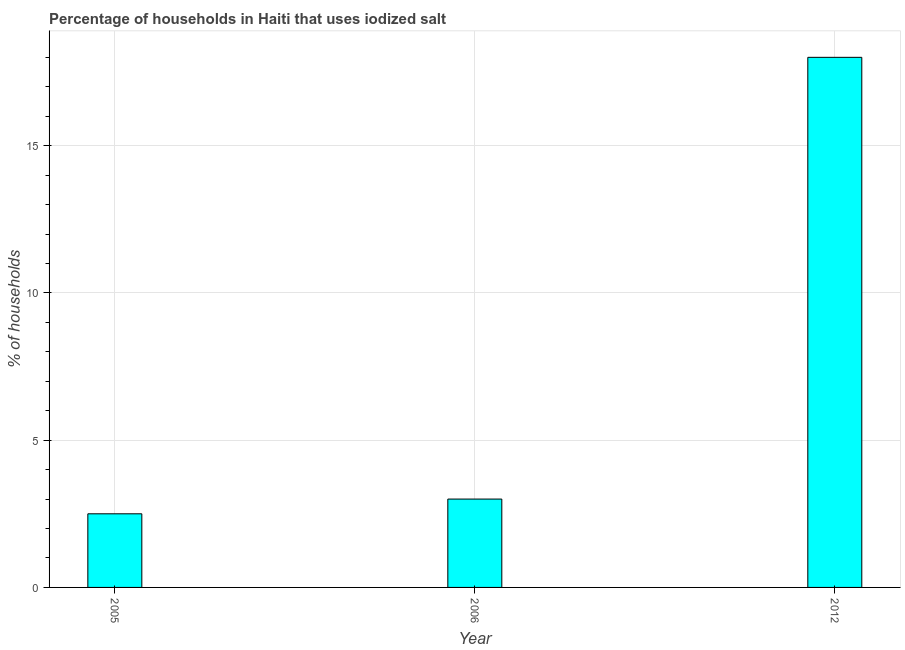Does the graph contain any zero values?
Give a very brief answer. No. What is the title of the graph?
Ensure brevity in your answer.  Percentage of households in Haiti that uses iodized salt. What is the label or title of the X-axis?
Provide a short and direct response. Year. What is the label or title of the Y-axis?
Offer a very short reply. % of households. What is the percentage of households where iodized salt is consumed in 2005?
Keep it short and to the point. 2.5. Across all years, what is the maximum percentage of households where iodized salt is consumed?
Make the answer very short. 18. Across all years, what is the minimum percentage of households where iodized salt is consumed?
Ensure brevity in your answer.  2.5. In which year was the percentage of households where iodized salt is consumed minimum?
Keep it short and to the point. 2005. What is the sum of the percentage of households where iodized salt is consumed?
Give a very brief answer. 23.5. What is the difference between the percentage of households where iodized salt is consumed in 2005 and 2012?
Your response must be concise. -15.5. What is the average percentage of households where iodized salt is consumed per year?
Provide a short and direct response. 7.83. In how many years, is the percentage of households where iodized salt is consumed greater than 13 %?
Your answer should be compact. 1. What is the ratio of the percentage of households where iodized salt is consumed in 2005 to that in 2012?
Your response must be concise. 0.14. Is the difference between the percentage of households where iodized salt is consumed in 2005 and 2012 greater than the difference between any two years?
Your answer should be compact. Yes. What is the difference between the highest and the second highest percentage of households where iodized salt is consumed?
Your answer should be very brief. 15. In how many years, is the percentage of households where iodized salt is consumed greater than the average percentage of households where iodized salt is consumed taken over all years?
Keep it short and to the point. 1. How many bars are there?
Your answer should be compact. 3. Are all the bars in the graph horizontal?
Ensure brevity in your answer.  No. What is the % of households of 2005?
Your answer should be compact. 2.5. What is the difference between the % of households in 2005 and 2012?
Ensure brevity in your answer.  -15.5. What is the ratio of the % of households in 2005 to that in 2006?
Offer a very short reply. 0.83. What is the ratio of the % of households in 2005 to that in 2012?
Offer a terse response. 0.14. What is the ratio of the % of households in 2006 to that in 2012?
Make the answer very short. 0.17. 